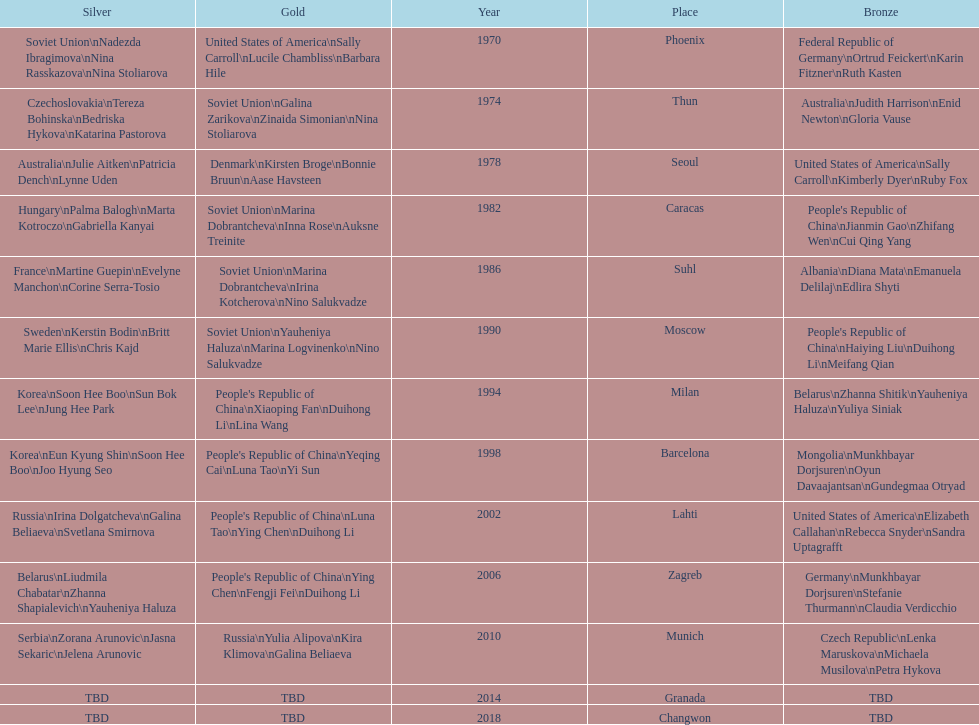How many times has germany won bronze? 2. 